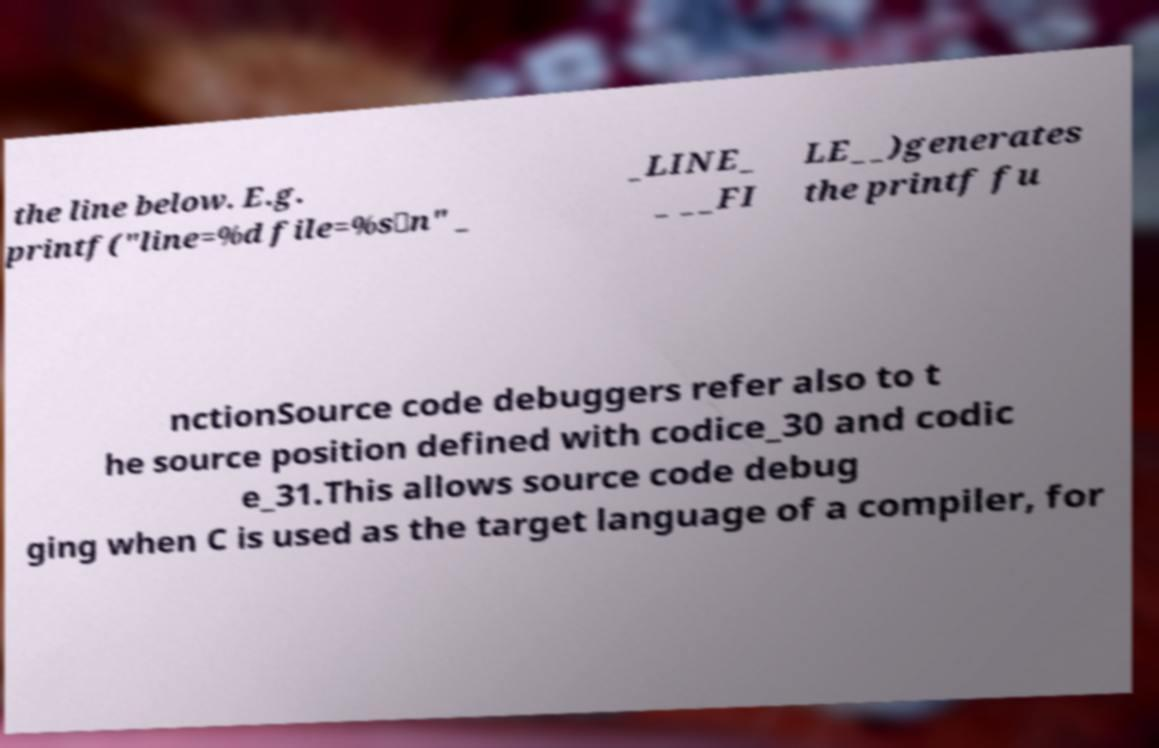What messages or text are displayed in this image? I need them in a readable, typed format. the line below. E.g. printf("line=%d file=%s\n" _ _LINE_ _ __FI LE__)generates the printf fu nctionSource code debuggers refer also to t he source position defined with codice_30 and codic e_31.This allows source code debug ging when C is used as the target language of a compiler, for 